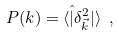Convert formula to latex. <formula><loc_0><loc_0><loc_500><loc_500>P ( k ) = \langle \hat { | } \delta _ { \vec { k } } ^ { 2 } | \rangle \ ,</formula> 